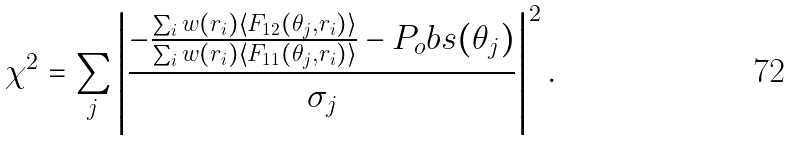Convert formula to latex. <formula><loc_0><loc_0><loc_500><loc_500>\chi ^ { 2 } = \sum _ { j } \left | \frac { - \frac { \sum _ { i } w ( r _ { i } ) \left < F _ { 1 2 } ( \theta _ { j } , r _ { i } ) \right > } { \sum _ { i } w ( r _ { i } ) \left < F _ { 1 1 } ( \theta _ { j } , r _ { i } ) \right > } - P _ { o } b s ( \theta _ { j } ) } { \sigma _ { j } } \right | ^ { 2 } .</formula> 